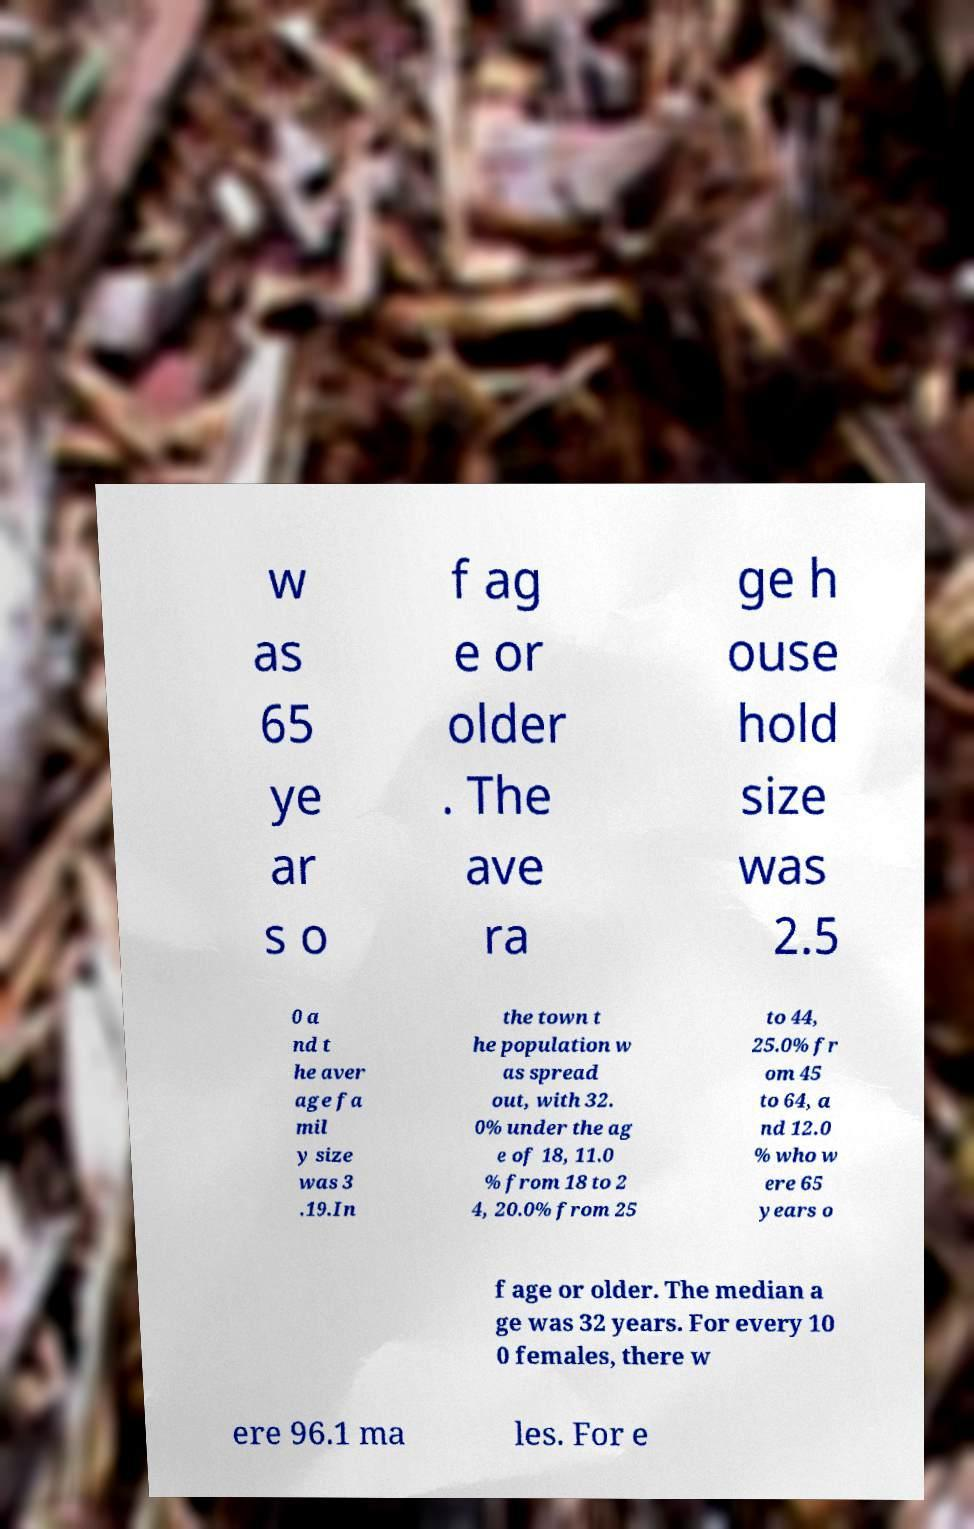I need the written content from this picture converted into text. Can you do that? w as 65 ye ar s o f ag e or older . The ave ra ge h ouse hold size was 2.5 0 a nd t he aver age fa mil y size was 3 .19.In the town t he population w as spread out, with 32. 0% under the ag e of 18, 11.0 % from 18 to 2 4, 20.0% from 25 to 44, 25.0% fr om 45 to 64, a nd 12.0 % who w ere 65 years o f age or older. The median a ge was 32 years. For every 10 0 females, there w ere 96.1 ma les. For e 